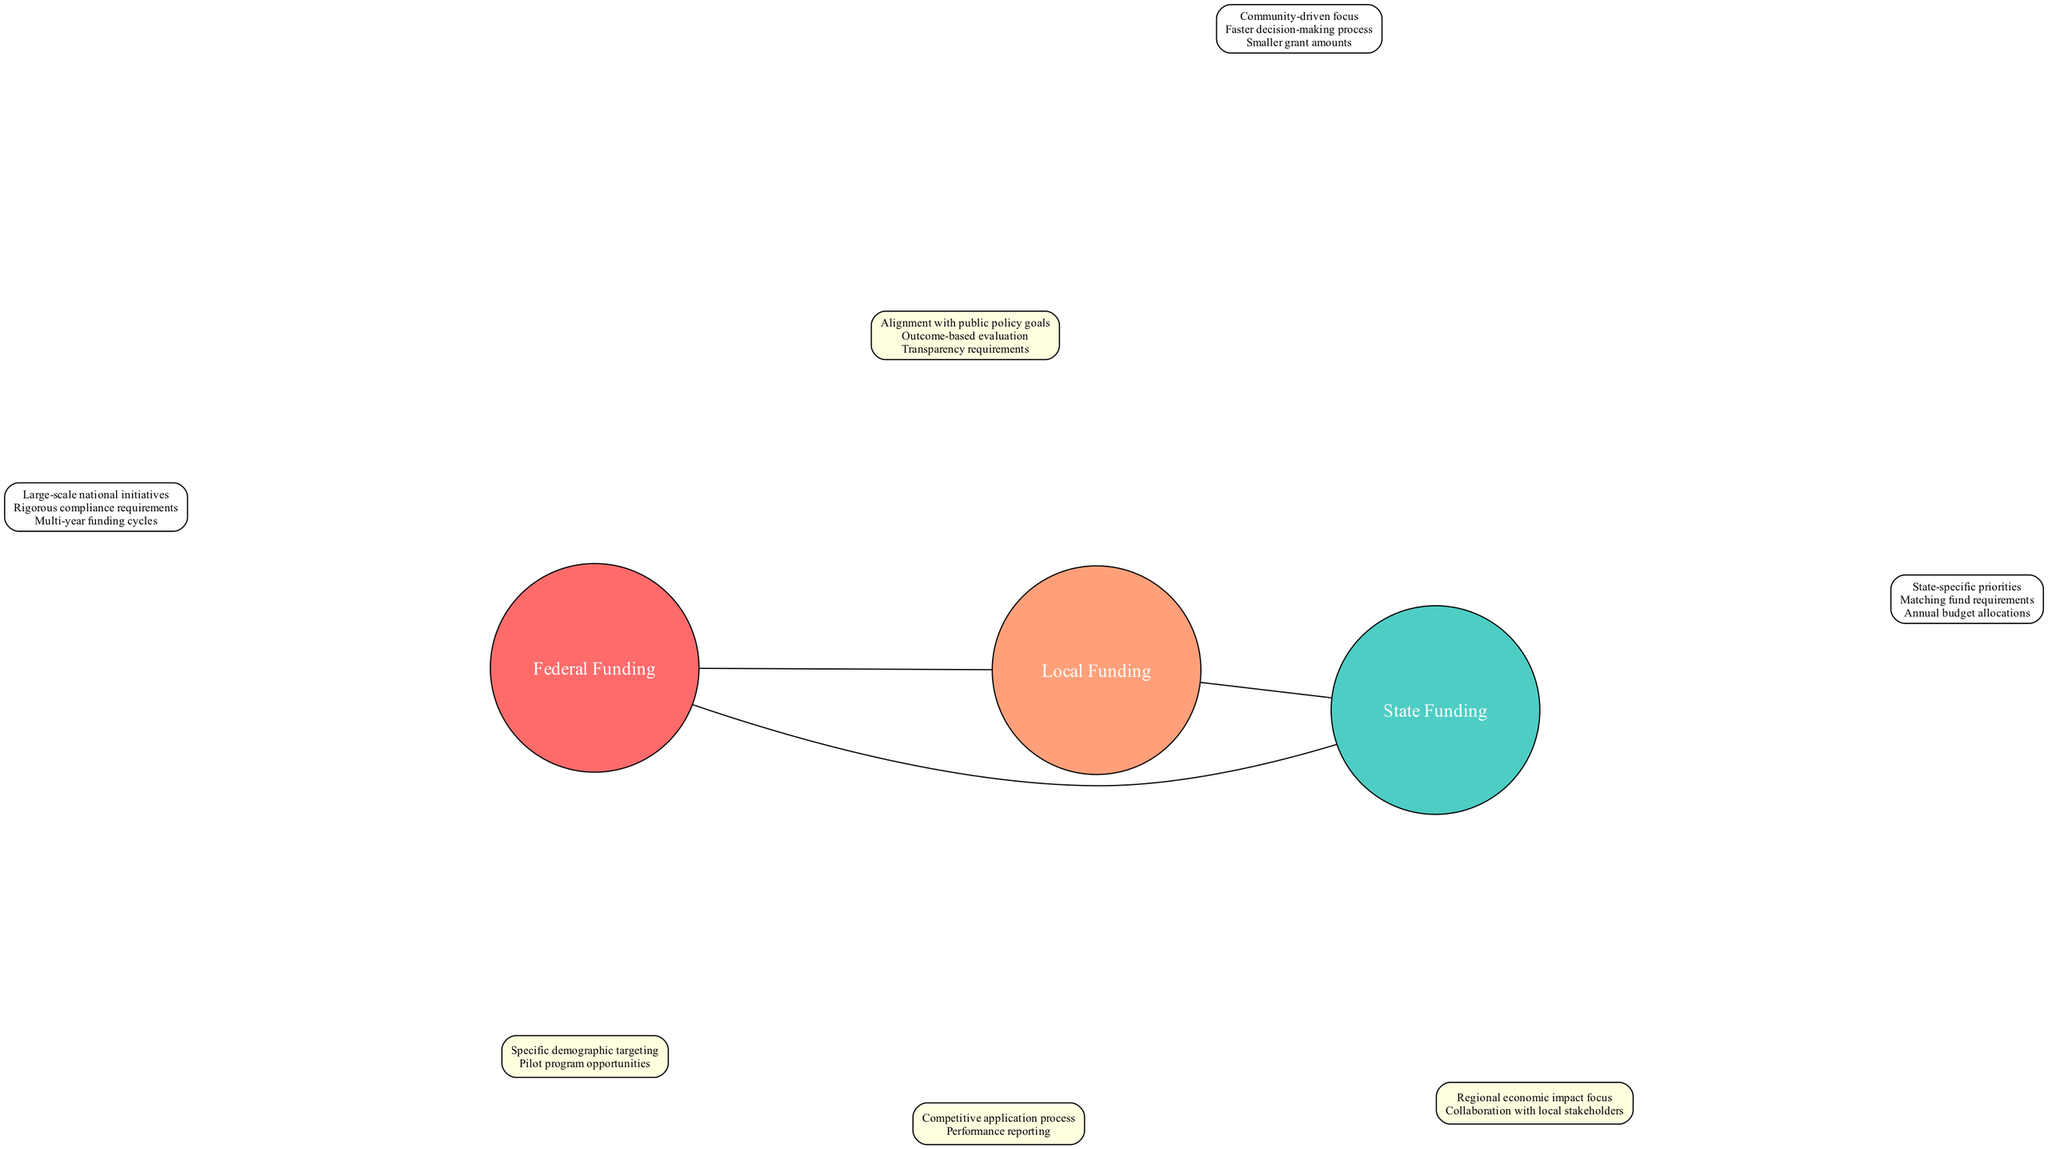What are the unique characteristics of Federal Funding? The unique characteristics of Federal Funding are displayed within the respective circle and include "Large-scale national initiatives," "Rigorous compliance requirements," and "Multi-year funding cycles."
Answer: Large-scale national initiatives, Rigorous compliance requirements, Multi-year funding cycles How many unique characteristics does Local Funding have? By inspecting the Local Funding circle, we find three unique characteristics listed without any overlaps with other funding types, which totals to three.
Answer: 3 What characteristics are shared between State Funding and Local Funding? The overlapping characteristics between State Funding and Local Funding, displayed in the intersection area of the two circles, include "Regional economic impact focus" and "Collaboration with local stakeholders."
Answer: Regional economic impact focus, Collaboration with local stakeholders Which funding type has a faster decision-making process? The characteristic of a faster decision-making process is unique to the Local Funding circle, indicating that Local Funding has this feature.
Answer: Local Funding What do all three funding sources have in common? The common characteristics shared by Federal, State, and Local Funding are listed in the intersection at the center of the diagram and include "Alignment with public policy goals," "Outcome-based evaluation," and "Transparency requirements."
Answer: Alignment with public policy goals, Outcome-based evaluation, Transparency requirements What is a unique requirement of State Funding? The unique characteristic of State Funding is the "Matching fund requirements," shown in its respective circle, indicating that to receive state funding, matching funds may be necessary.
Answer: Matching fund requirements Which two funding types have specific demographic targeting? The characteristic of specific demographic targeting is shared between Federal Funding and Local Funding, as indicated in the overlapping portion between their circles.
Answer: Federal Funding, Local Funding How does Local Funding prioritize grant amounts compared to other sources? The diagram displays that Local Funding provides "Smaller grant amounts" compared to the larger scales of Federal and State Funding, which indicates that it focuses on providing limited financial resources.
Answer: Smaller grant amounts What is the tenor of funding associated with Federal sources? The unique characteristic "Multi-year funding cycles" indicates that federal funding generally extends over multiple years for its financial commitments.
Answer: Multi-year funding cycles 